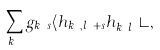Convert formula to latex. <formula><loc_0><loc_0><loc_500><loc_500>\sum _ { k _ { y } } g _ { k _ { y } s } \langle h _ { k _ { y } , l _ { x } + s } h ^ { \dagger } _ { k _ { y } l _ { x } } \rangle ,</formula> 